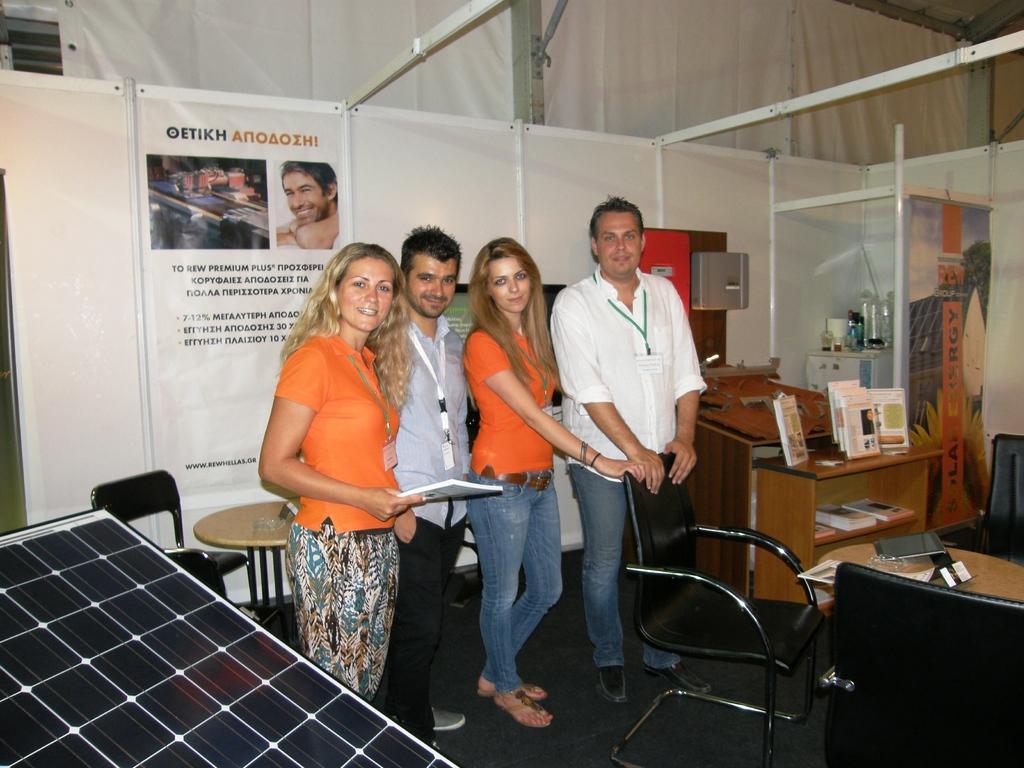Please provide a concise description of this image. In the middle I can see four persons are standing on the floor, chairs, tables, some objects, books, photo frames and a laptop. In the background I can see boards, posters, wall, metal rods, window and a rooftop. This image is taken may be in a hall. 